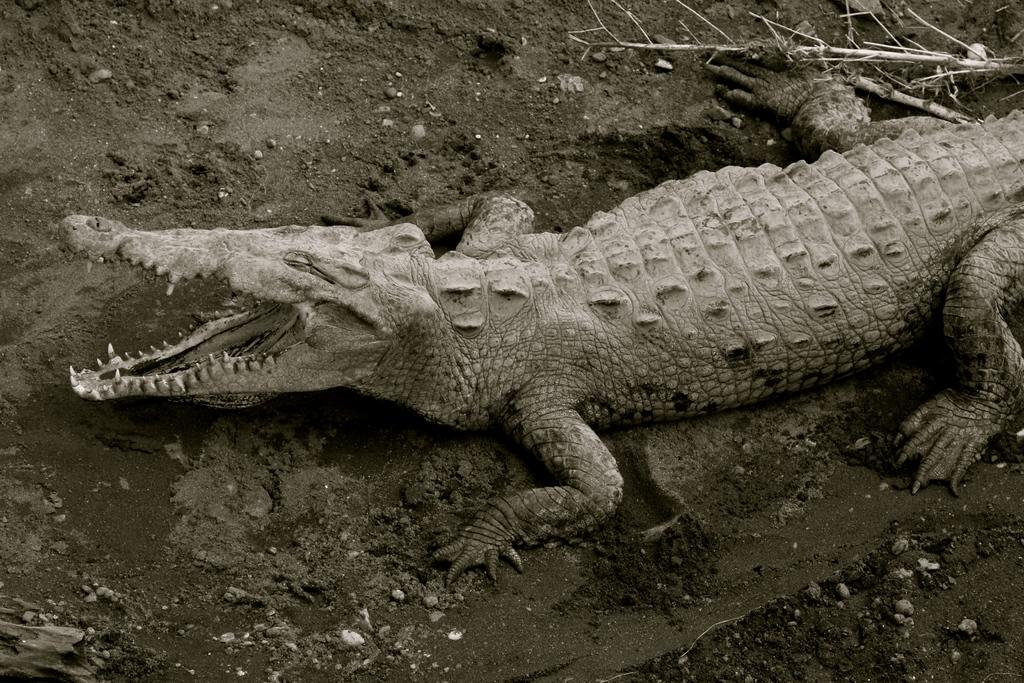What type of animal is present in the image? There is an alligator in the image. What type of room is the alligator in during the conversation? The image does not depict a room, nor does it show a conversation taking place. The alligator is simply present in the image. 